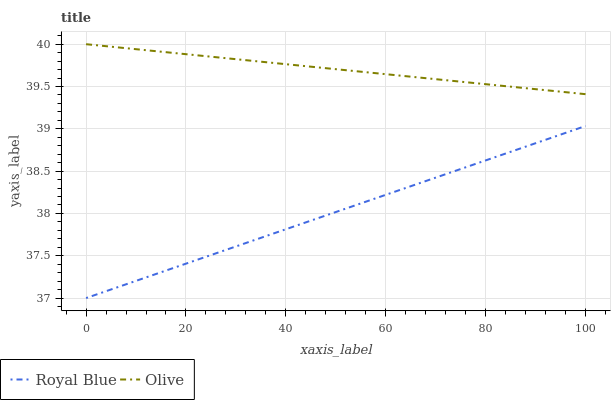Does Royal Blue have the minimum area under the curve?
Answer yes or no. Yes. Does Olive have the maximum area under the curve?
Answer yes or no. Yes. Does Royal Blue have the maximum area under the curve?
Answer yes or no. No. Is Royal Blue the smoothest?
Answer yes or no. Yes. Is Olive the roughest?
Answer yes or no. Yes. Is Royal Blue the roughest?
Answer yes or no. No. Does Royal Blue have the lowest value?
Answer yes or no. Yes. Does Olive have the highest value?
Answer yes or no. Yes. Does Royal Blue have the highest value?
Answer yes or no. No. Is Royal Blue less than Olive?
Answer yes or no. Yes. Is Olive greater than Royal Blue?
Answer yes or no. Yes. Does Royal Blue intersect Olive?
Answer yes or no. No. 